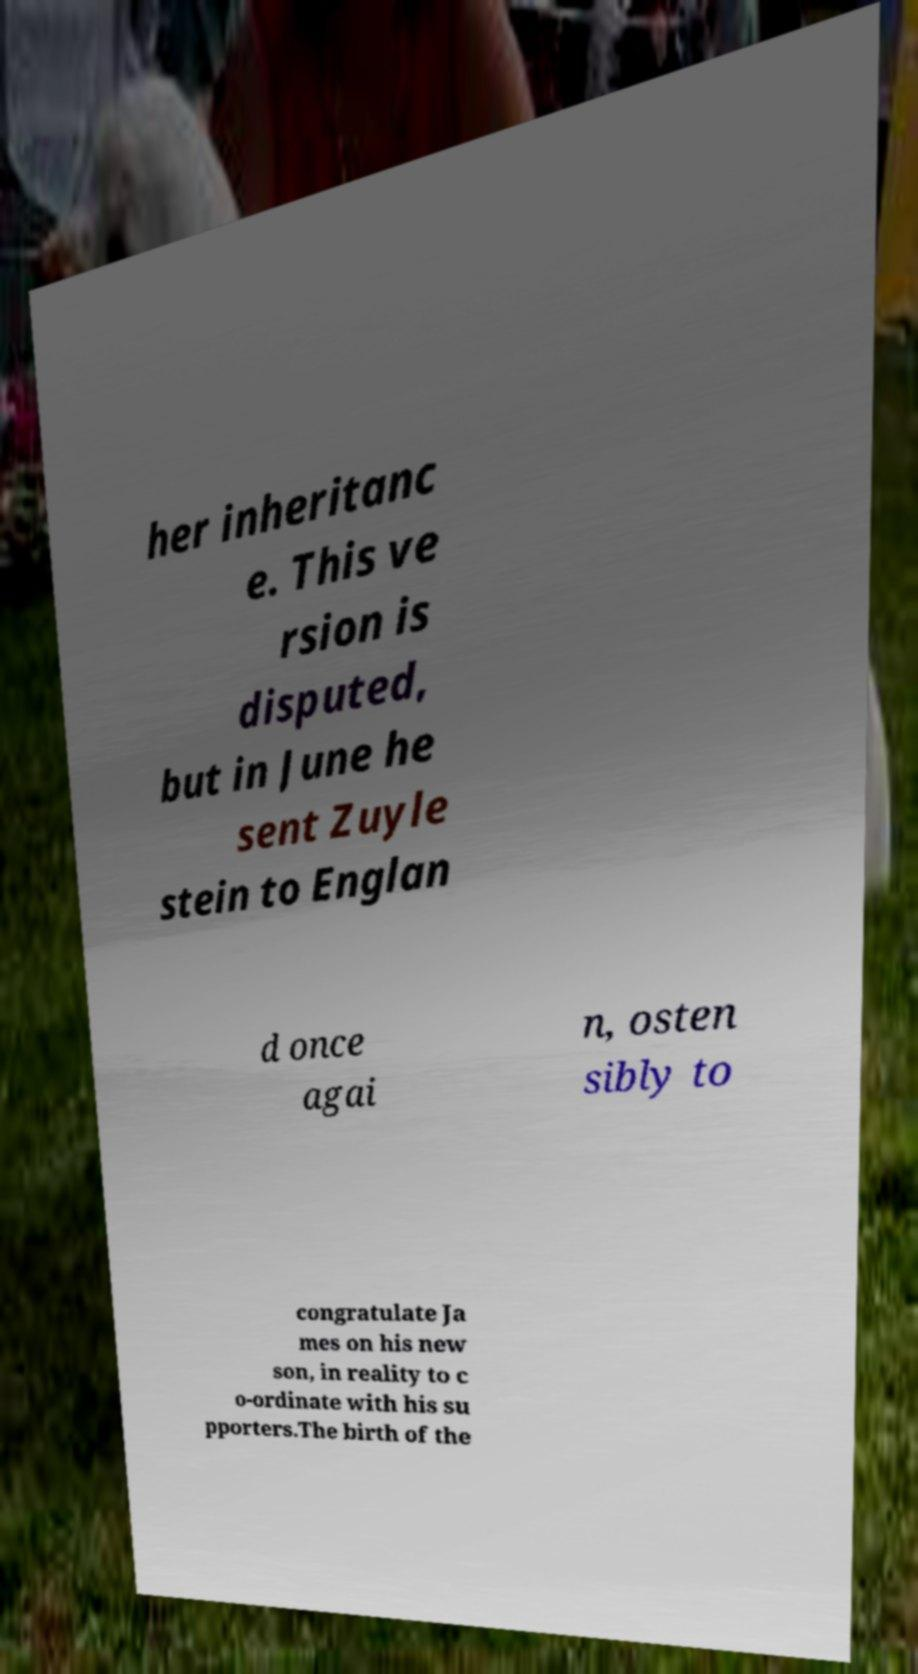What messages or text are displayed in this image? I need them in a readable, typed format. her inheritanc e. This ve rsion is disputed, but in June he sent Zuyle stein to Englan d once agai n, osten sibly to congratulate Ja mes on his new son, in reality to c o-ordinate with his su pporters.The birth of the 